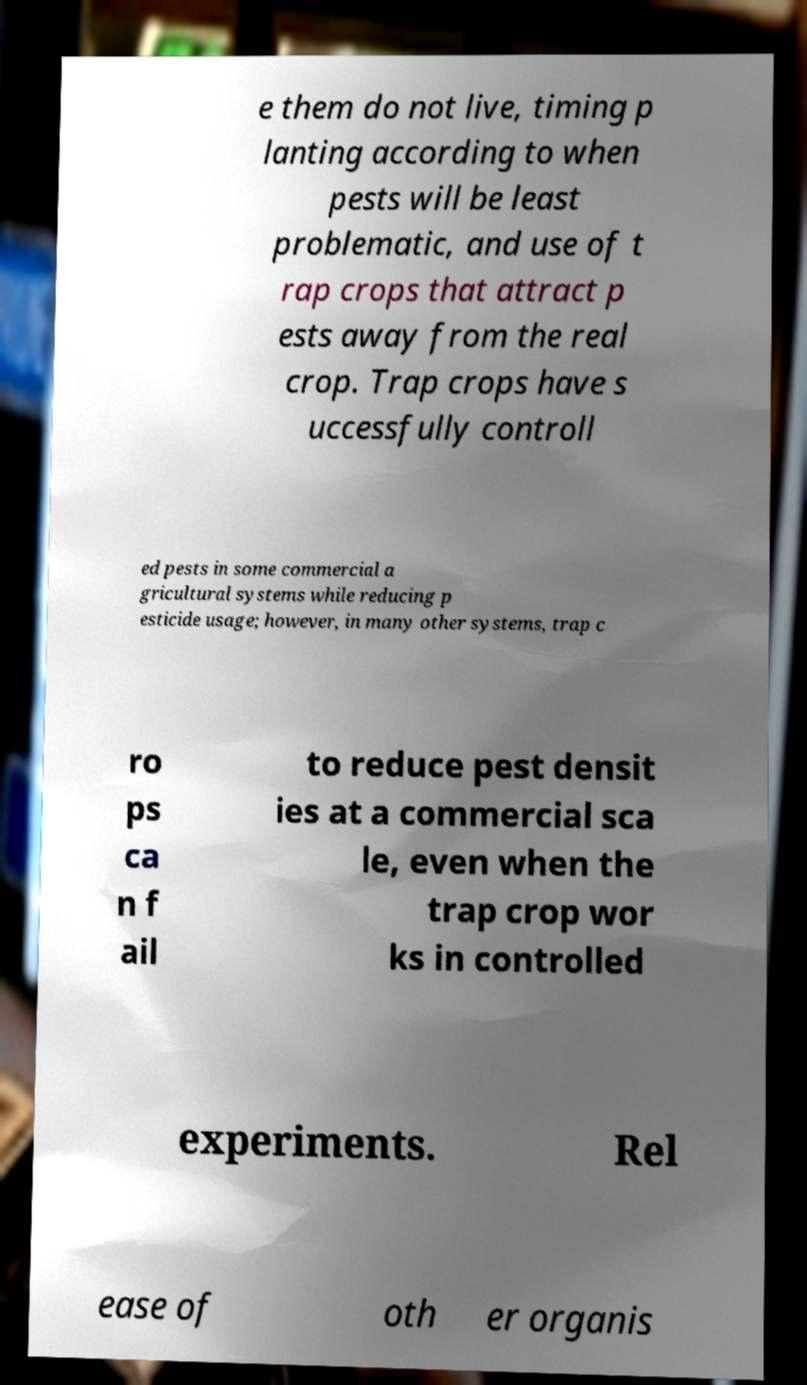Could you extract and type out the text from this image? e them do not live, timing p lanting according to when pests will be least problematic, and use of t rap crops that attract p ests away from the real crop. Trap crops have s uccessfully controll ed pests in some commercial a gricultural systems while reducing p esticide usage; however, in many other systems, trap c ro ps ca n f ail to reduce pest densit ies at a commercial sca le, even when the trap crop wor ks in controlled experiments. Rel ease of oth er organis 